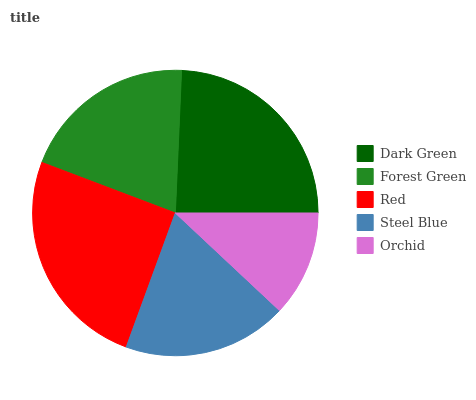Is Orchid the minimum?
Answer yes or no. Yes. Is Red the maximum?
Answer yes or no. Yes. Is Forest Green the minimum?
Answer yes or no. No. Is Forest Green the maximum?
Answer yes or no. No. Is Dark Green greater than Forest Green?
Answer yes or no. Yes. Is Forest Green less than Dark Green?
Answer yes or no. Yes. Is Forest Green greater than Dark Green?
Answer yes or no. No. Is Dark Green less than Forest Green?
Answer yes or no. No. Is Forest Green the high median?
Answer yes or no. Yes. Is Forest Green the low median?
Answer yes or no. Yes. Is Steel Blue the high median?
Answer yes or no. No. Is Dark Green the low median?
Answer yes or no. No. 